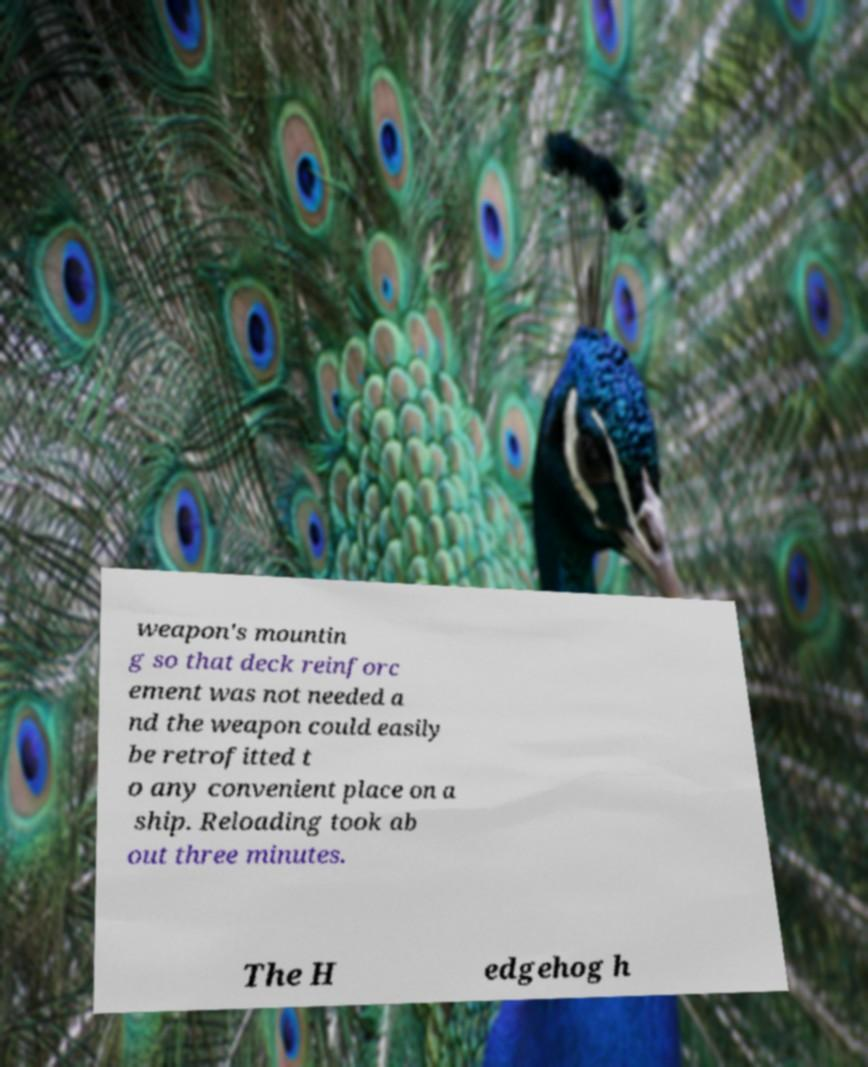For documentation purposes, I need the text within this image transcribed. Could you provide that? weapon's mountin g so that deck reinforc ement was not needed a nd the weapon could easily be retrofitted t o any convenient place on a ship. Reloading took ab out three minutes. The H edgehog h 